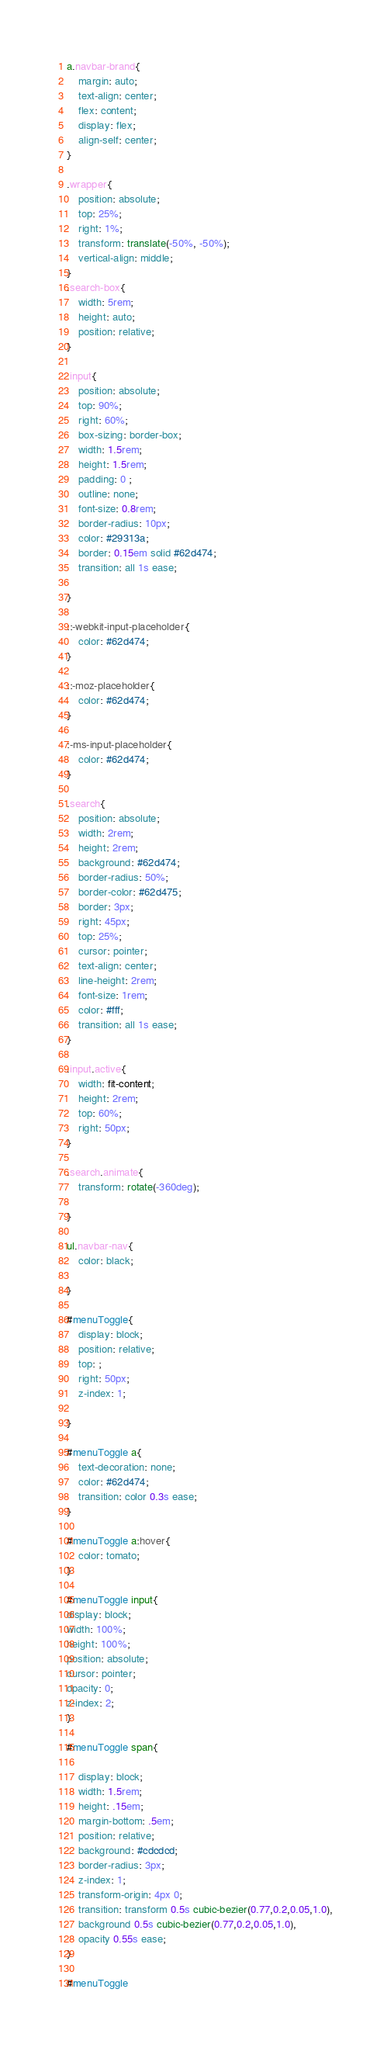Convert code to text. <code><loc_0><loc_0><loc_500><loc_500><_CSS_>a.navbar-brand{
    margin: auto;
    text-align: center;
    flex: content;
    display: flex;
    align-self: center;
}

.wrapper{
    position: absolute;
    top: 25%;
    right: 1%;
    transform: translate(-50%, -50%);
    vertical-align: middle;
}
.search-box{
    width: 5rem;
    height: auto;
    position: relative;
}

.input{
    position: absolute;
    top: 90%;
    right: 60%;
    box-sizing: border-box;
    width: 1.5rem;
    height: 1.5rem;
    padding: 0 ;
    outline: none;
    font-size: 0.8rem;
    border-radius: 10px;
    color: #29313a;
    border: 0.15em solid #62d474;
    transition: all 1s ease;

}

::-webkit-input-placeholder{
    color: #62d474;
}

::-moz-placeholder{
    color: #62d474;
}

:-ms-input-placeholder{
    color: #62d474;
}

.search{
    position: absolute;
    width: 2rem;
    height: 2rem;
    background: #62d474;
    border-radius: 50%;
    border-color: #62d475;
    border: 3px;
    right: 45px;
    top: 25%;
    cursor: pointer;
    text-align: center;
    line-height: 2rem;
    font-size: 1rem;
    color: #fff;
    transition: all 1s ease;
}

.input.active{
    width: fit-content;
    height: 2rem;
    top: 60%;
    right: 50px;
}

.search.animate{
    transform: rotate(-360deg);
    
}

ul.navbar-nav{
    color: black;

}

#menuToggle{
    display: block;
    position: relative;
    top: ;
    right: 50px;
    z-index: 1;

}

#menuToggle a{
    text-decoration: none;
    color: #62d474;
    transition: color 0.3s ease;
}

#menuToggle a:hover{
    color: tomato;
}

#menuToggle input{
display: block;
width: 100%;
height: 100%;
position: absolute;
cursor: pointer;
opacity: 0;
z-index: 2;
}

#menuToggle span{
    
    display: block;
    width: 1.5rem;
    height: .15em;
    margin-bottom: .5em;
    position: relative;
    background: #cdcdcd;
    border-radius: 3px;
    z-index: 1;
    transform-origin: 4px 0;
    transition: transform 0.5s cubic-bezier(0.77,0.2,0.05,1.0),
    background 0.5s cubic-bezier(0.77,0.2,0.05,1.0),
    opacity 0.55s ease;
}

#menuToggle</code> 